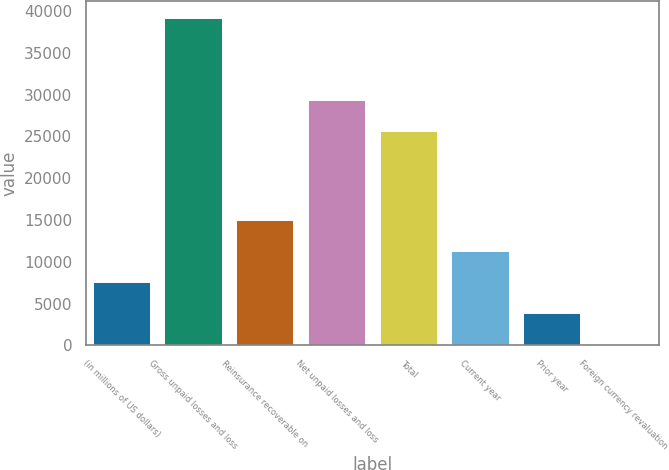Convert chart to OTSL. <chart><loc_0><loc_0><loc_500><loc_500><bar_chart><fcel>(in millions of US dollars)<fcel>Gross unpaid losses and loss<fcel>Reinsurance recoverable on<fcel>Net unpaid losses and loss<fcel>Total<fcel>Current year<fcel>Prior year<fcel>Foreign currency revaluation<nl><fcel>7556<fcel>39211.5<fcel>14945<fcel>29397<fcel>25702.5<fcel>11250.5<fcel>3861.5<fcel>167<nl></chart> 